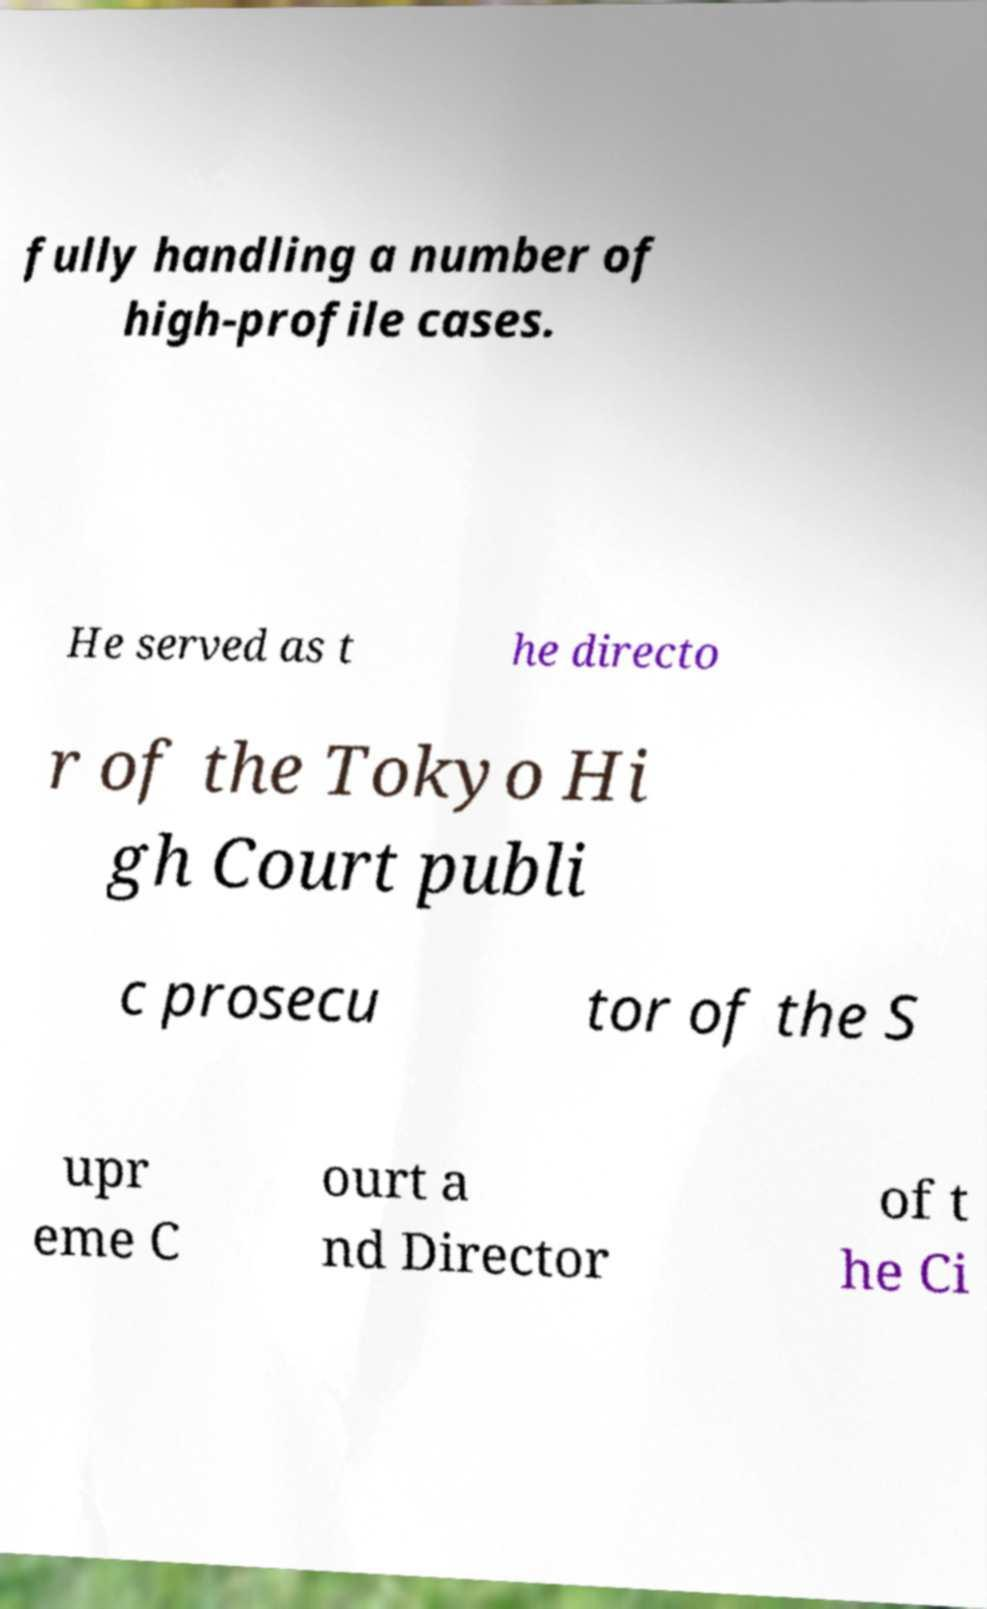Please identify and transcribe the text found in this image. fully handling a number of high-profile cases. He served as t he directo r of the Tokyo Hi gh Court publi c prosecu tor of the S upr eme C ourt a nd Director of t he Ci 